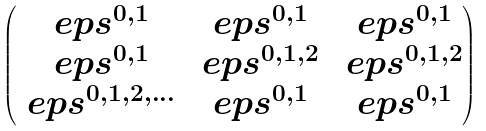<formula> <loc_0><loc_0><loc_500><loc_500>\begin{pmatrix} \ e p s ^ { 0 , 1 } & \ e p s ^ { 0 , 1 } & \ e p s ^ { 0 , 1 } \\ \ e p s ^ { 0 , 1 } & \ e p s ^ { 0 , 1 , 2 } & \ e p s ^ { 0 , 1 , 2 } \\ \ e p s ^ { 0 , 1 , 2 , \dots } & \ e p s ^ { 0 , 1 } & \ e p s ^ { 0 , 1 } \end{pmatrix}</formula> 